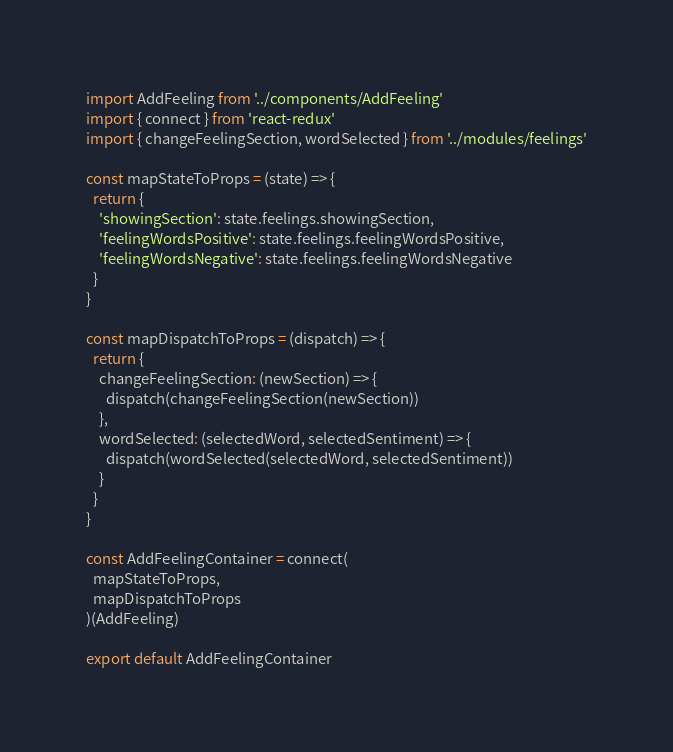Convert code to text. <code><loc_0><loc_0><loc_500><loc_500><_JavaScript_>import AddFeeling from '../components/AddFeeling'
import { connect } from 'react-redux'
import { changeFeelingSection, wordSelected } from '../modules/feelings'

const mapStateToProps = (state) => {
  return {
    'showingSection': state.feelings.showingSection,
    'feelingWordsPositive': state.feelings.feelingWordsPositive,
    'feelingWordsNegative': state.feelings.feelingWordsNegative
  }
}

const mapDispatchToProps = (dispatch) => {
  return {
    changeFeelingSection: (newSection) => {
      dispatch(changeFeelingSection(newSection))
    },
    wordSelected: (selectedWord, selectedSentiment) => {
      dispatch(wordSelected(selectedWord, selectedSentiment))
    }
  }
}

const AddFeelingContainer = connect(
  mapStateToProps,
  mapDispatchToProps
)(AddFeeling)

export default AddFeelingContainer
</code> 